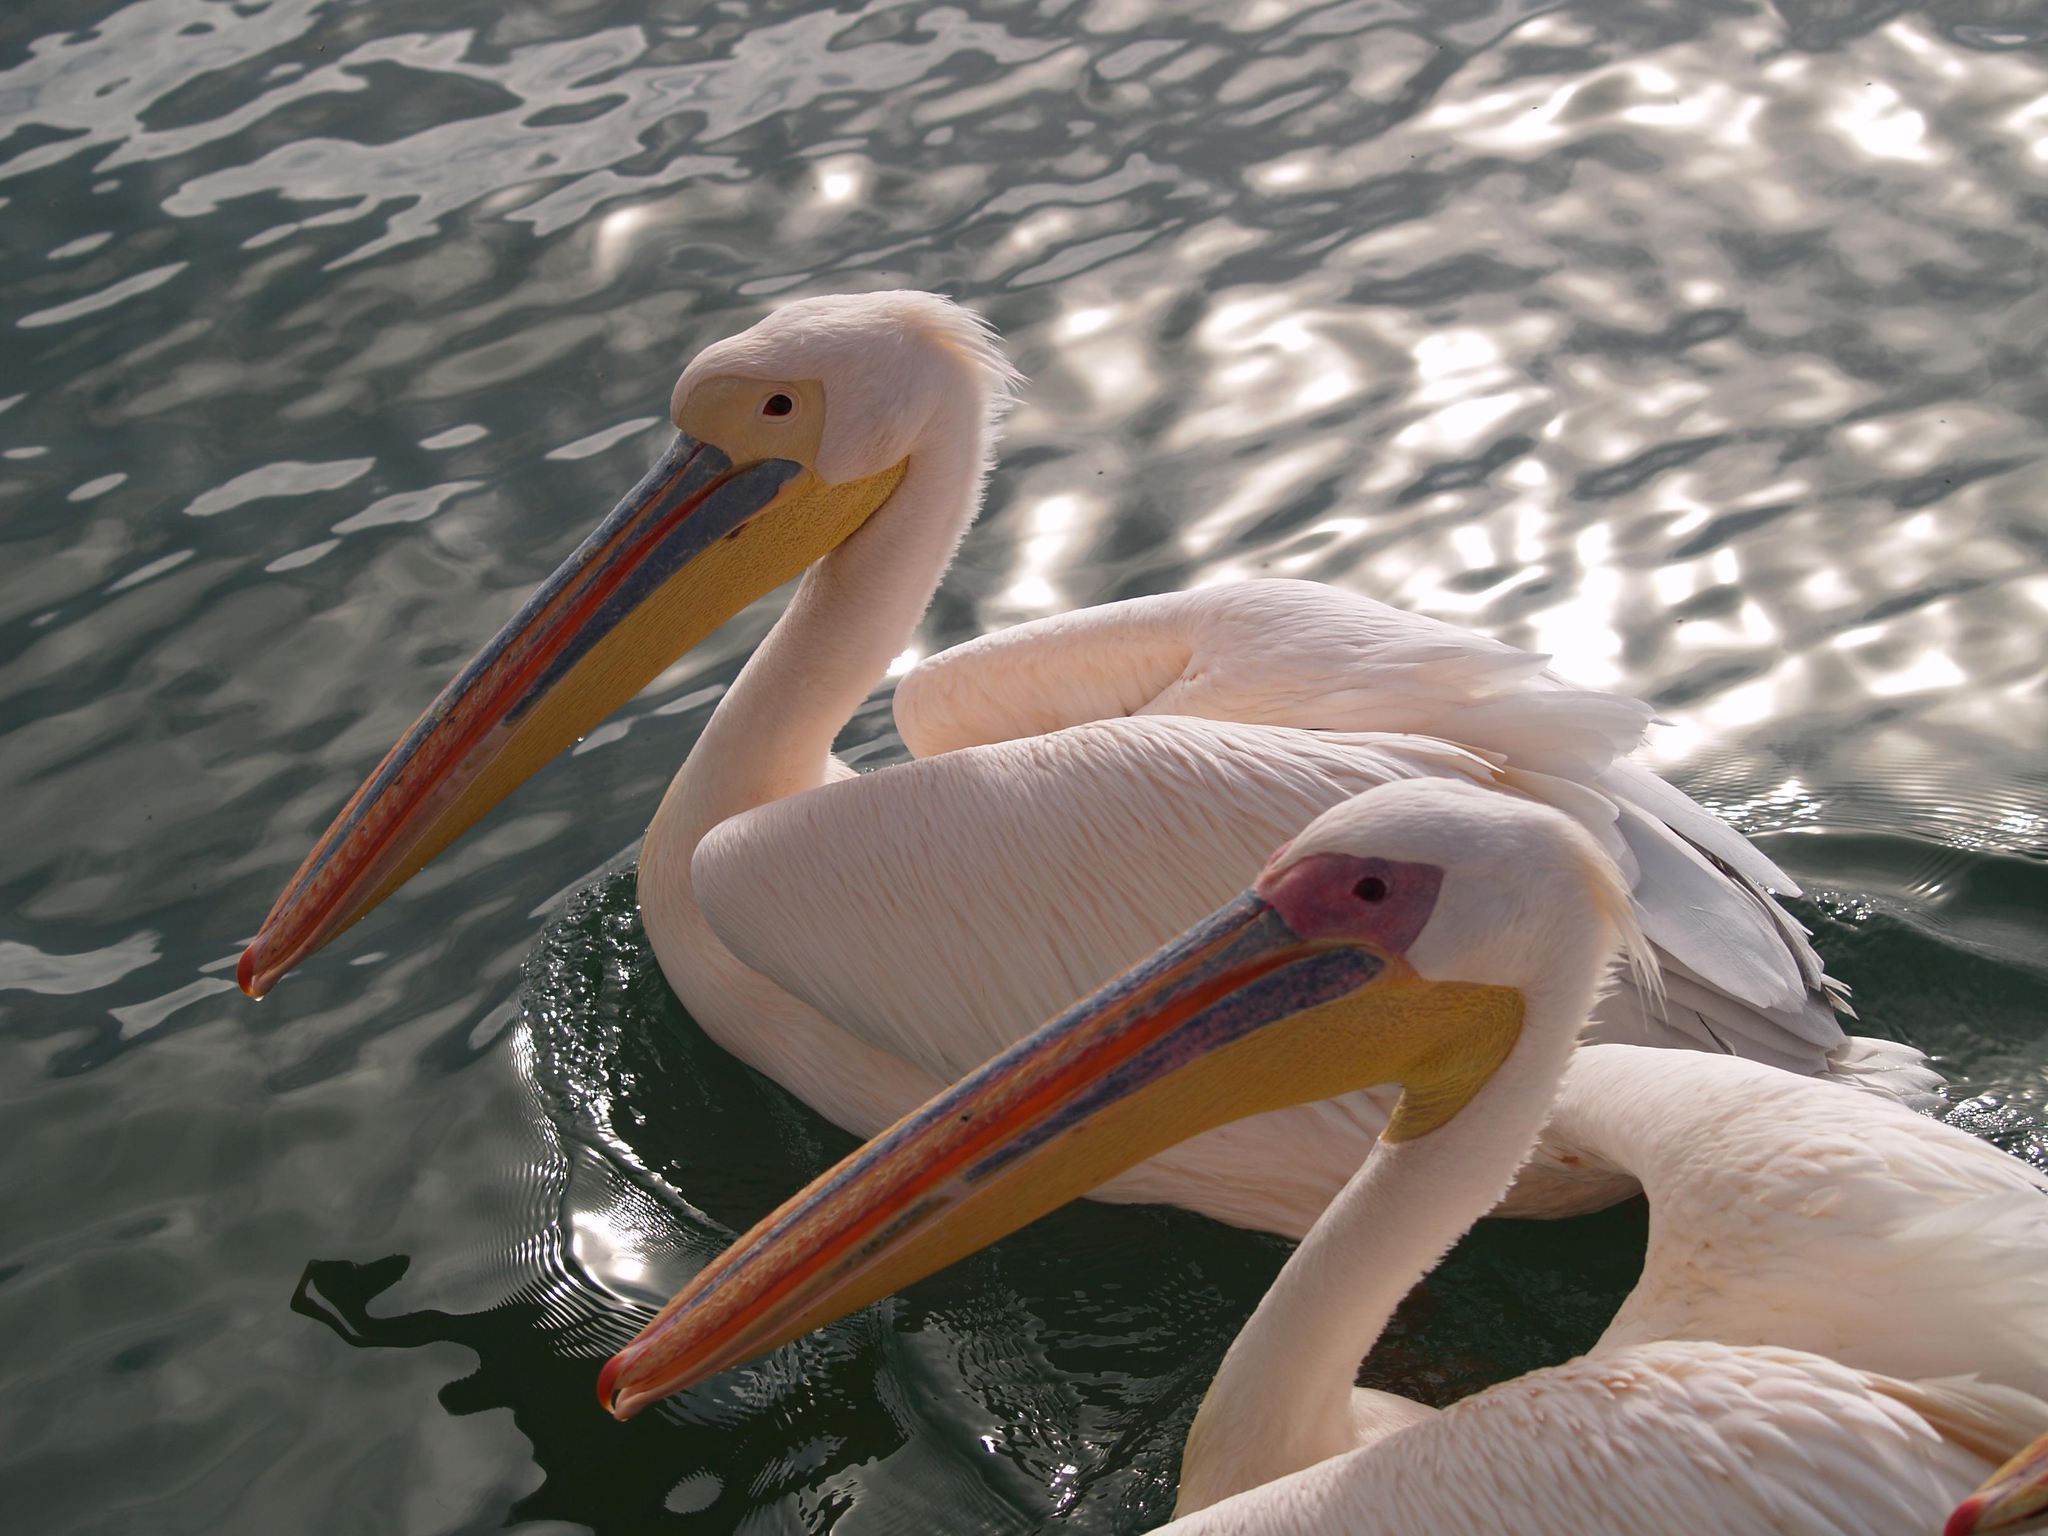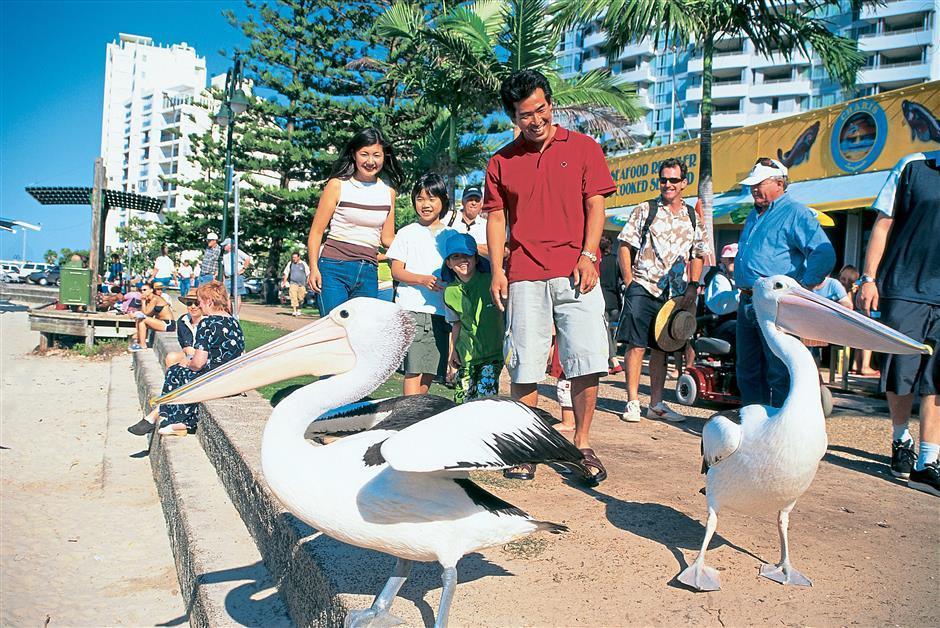The first image is the image on the left, the second image is the image on the right. Considering the images on both sides, is "A group of spectators are observing the pelicans." valid? Answer yes or no. Yes. The first image is the image on the left, the second image is the image on the right. Examine the images to the left and right. Is the description "There are more than 5 pelicans facing right." accurate? Answer yes or no. No. 